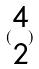Convert formula to latex. <formula><loc_0><loc_0><loc_500><loc_500>( \begin{matrix} 4 \\ 2 \end{matrix} )</formula> 